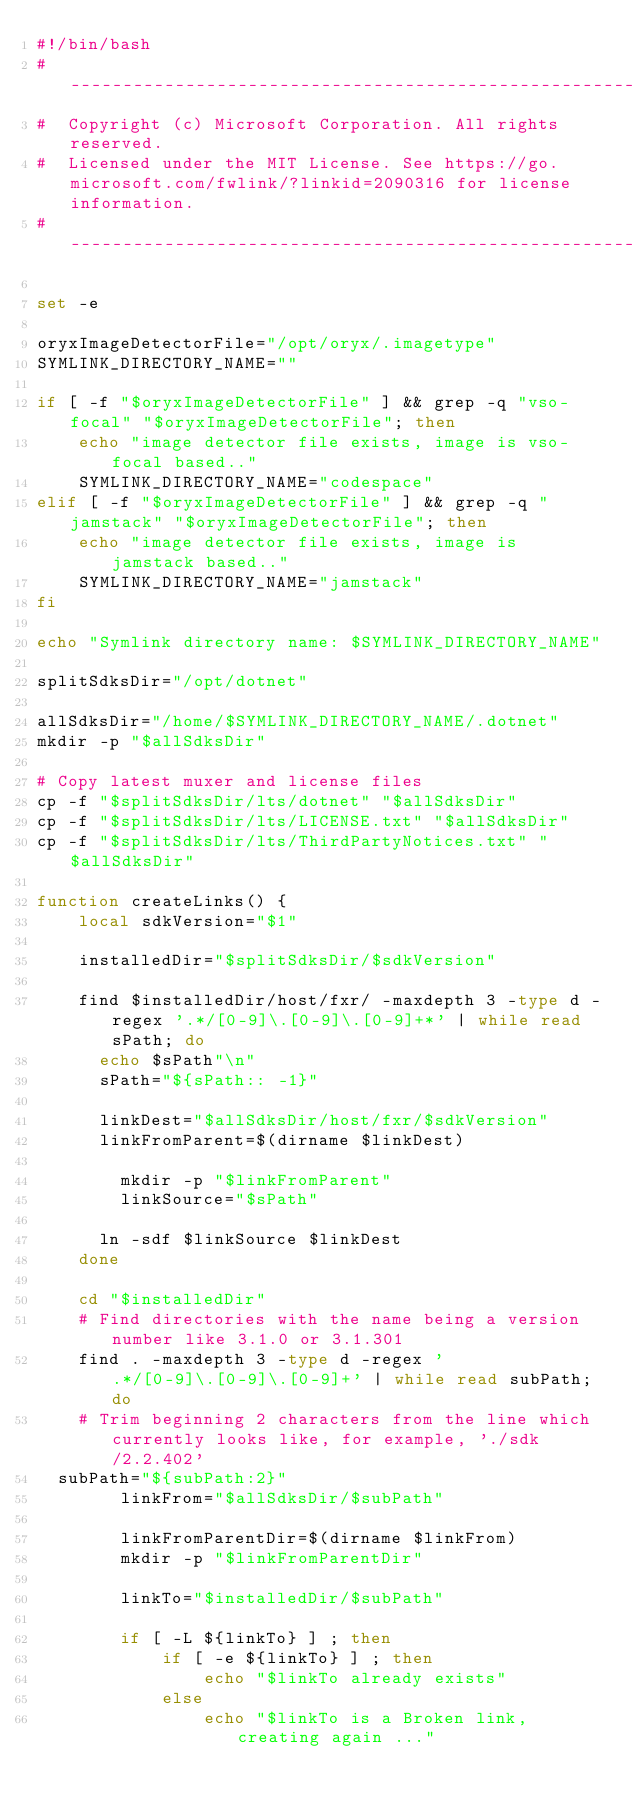<code> <loc_0><loc_0><loc_500><loc_500><_Bash_>#!/bin/bash
#--------------------------------------------------------------------------------------------------------------
#  Copyright (c) Microsoft Corporation. All rights reserved.
#  Licensed under the MIT License. See https://go.microsoft.com/fwlink/?linkid=2090316 for license information.
#--------------------------------------------------------------------------------------------------------------

set -e

oryxImageDetectorFile="/opt/oryx/.imagetype"
SYMLINK_DIRECTORY_NAME=""

if [ -f "$oryxImageDetectorFile" ] && grep -q "vso-focal" "$oryxImageDetectorFile"; then
    echo "image detector file exists, image is vso-focal based.."
    SYMLINK_DIRECTORY_NAME="codespace"
elif [ -f "$oryxImageDetectorFile" ] && grep -q "jamstack" "$oryxImageDetectorFile"; then                
    echo "image detector file exists, image is jamstack based.."
    SYMLINK_DIRECTORY_NAME="jamstack"
fi

echo "Symlink directory name: $SYMLINK_DIRECTORY_NAME"

splitSdksDir="/opt/dotnet"

allSdksDir="/home/$SYMLINK_DIRECTORY_NAME/.dotnet"
mkdir -p "$allSdksDir"

# Copy latest muxer and license files
cp -f "$splitSdksDir/lts/dotnet" "$allSdksDir"
cp -f "$splitSdksDir/lts/LICENSE.txt" "$allSdksDir"
cp -f "$splitSdksDir/lts/ThirdPartyNotices.txt" "$allSdksDir"

function createLinks() {
    local sdkVersion="$1"
    
    installedDir="$splitSdksDir/$sdkVersion"

    find $installedDir/host/fxr/ -maxdepth 3 -type d -regex '.*/[0-9]\.[0-9]\.[0-9]+*' | while read sPath; do
	    echo $sPath"\n"
	    sPath="${sPath:: -1}"
	    
	    linkDest="$allSdksDir/host/fxr/$sdkVersion"
	    linkFromParent=$(dirname $linkDest)
          
        mkdir -p "$linkFromParent"
        linkSource="$sPath"

	    ln -sdf $linkSource $linkDest
    done
    
    cd "$installedDir"
    # Find directories with the name being a version number like 3.1.0 or 3.1.301
    find . -maxdepth 3 -type d -regex '.*/[0-9]\.[0-9]\.[0-9]+' | while read subPath; do
    # Trim beginning 2 characters from the line which currently looks like, for example, './sdk/2.2.402'
	subPath="${subPath:2}"
        linkFrom="$allSdksDir/$subPath"

        linkFromParentDir=$(dirname $linkFrom)
        mkdir -p "$linkFromParentDir"

        linkTo="$installedDir/$subPath"
        
        if [ -L ${linkTo} ] ; then
            if [ -e ${linkTo} ] ; then
                echo "$linkTo already exists"
            else
                echo "$linkTo is a Broken link, creating again ..."</code> 